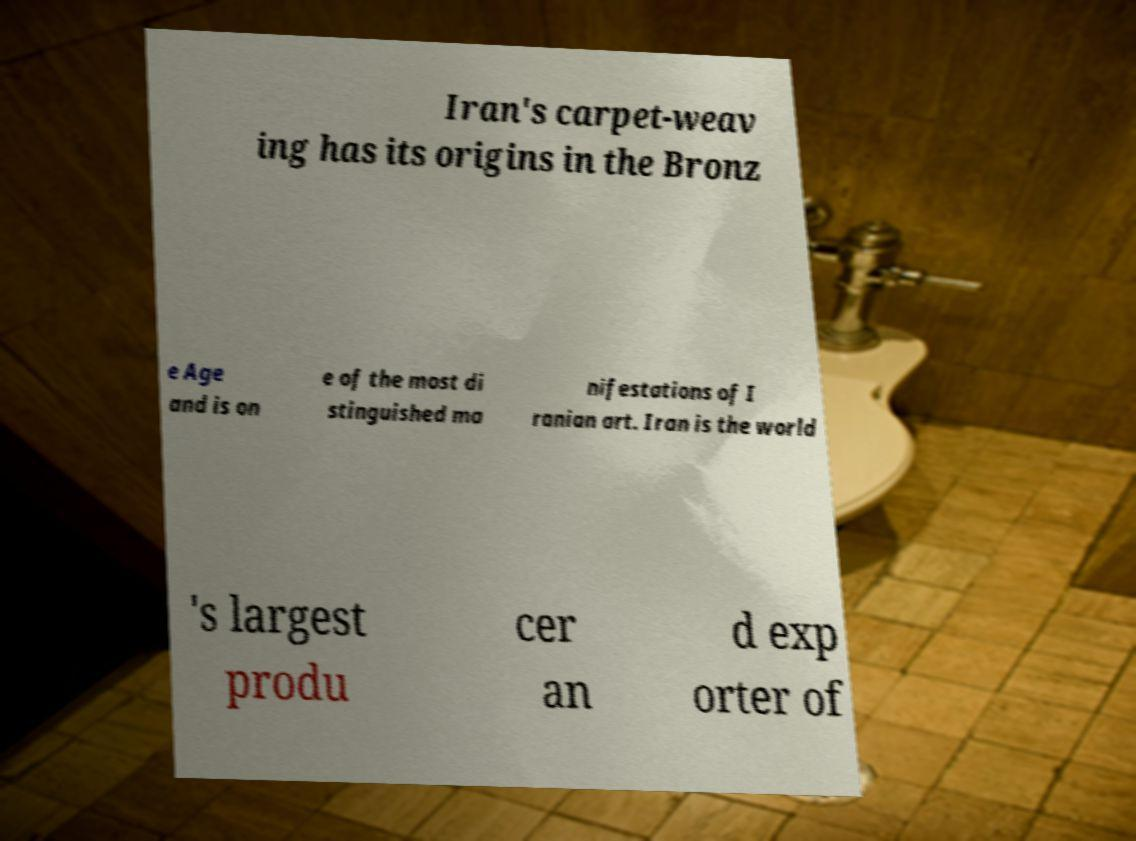Can you read and provide the text displayed in the image?This photo seems to have some interesting text. Can you extract and type it out for me? Iran's carpet-weav ing has its origins in the Bronz e Age and is on e of the most di stinguished ma nifestations of I ranian art. Iran is the world 's largest produ cer an d exp orter of 